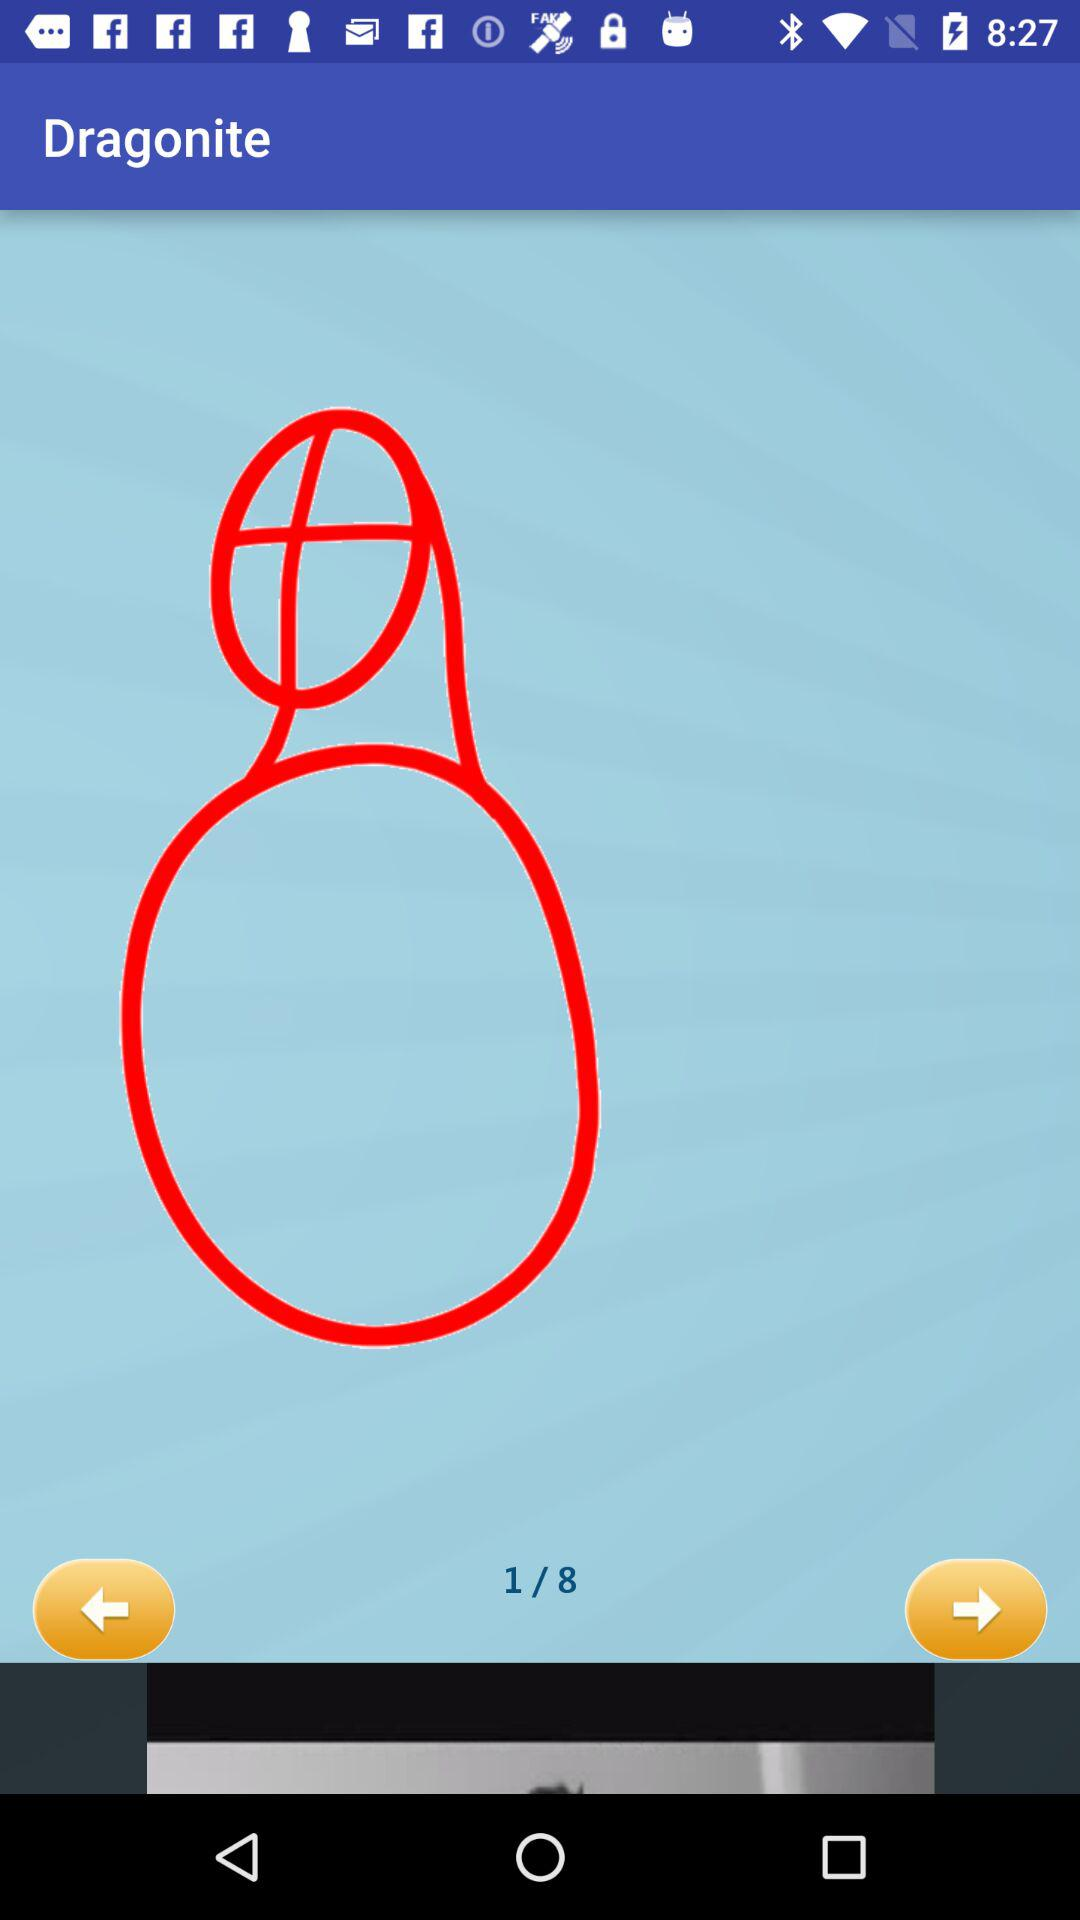Which image are we currently on? You are currently on the first image. 